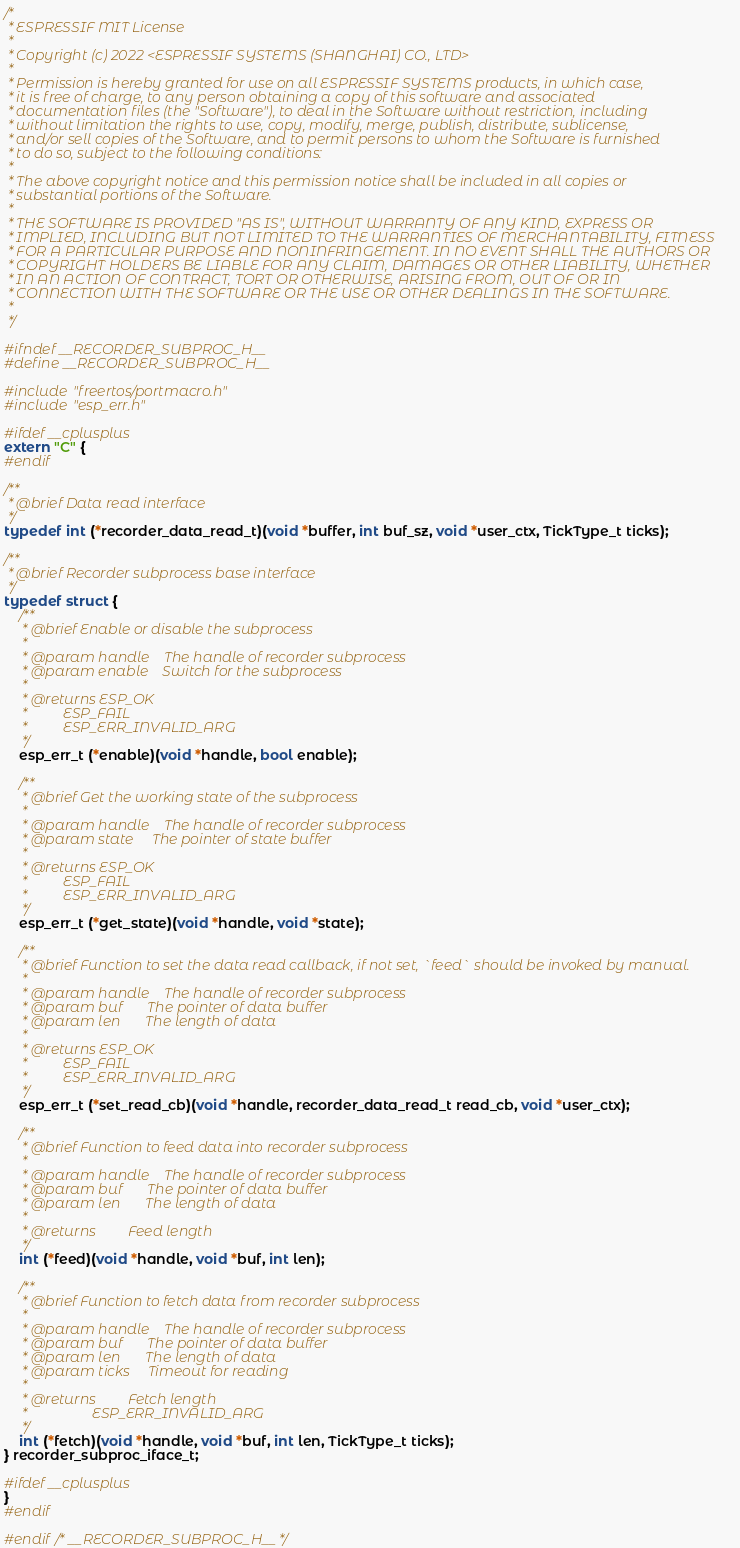Convert code to text. <code><loc_0><loc_0><loc_500><loc_500><_C_>/*
 * ESPRESSIF MIT License
 *
 * Copyright (c) 2022 <ESPRESSIF SYSTEMS (SHANGHAI) CO., LTD>
 *
 * Permission is hereby granted for use on all ESPRESSIF SYSTEMS products, in which case,
 * it is free of charge, to any person obtaining a copy of this software and associated
 * documentation files (the "Software"), to deal in the Software without restriction, including
 * without limitation the rights to use, copy, modify, merge, publish, distribute, sublicense,
 * and/or sell copies of the Software, and to permit persons to whom the Software is furnished
 * to do so, subject to the following conditions:
 *
 * The above copyright notice and this permission notice shall be included in all copies or
 * substantial portions of the Software.
 *
 * THE SOFTWARE IS PROVIDED "AS IS", WITHOUT WARRANTY OF ANY KIND, EXPRESS OR
 * IMPLIED, INCLUDING BUT NOT LIMITED TO THE WARRANTIES OF MERCHANTABILITY, FITNESS
 * FOR A PARTICULAR PURPOSE AND NONINFRINGEMENT. IN NO EVENT SHALL THE AUTHORS OR
 * COPYRIGHT HOLDERS BE LIABLE FOR ANY CLAIM, DAMAGES OR OTHER LIABILITY, WHETHER
 * IN AN ACTION OF CONTRACT, TORT OR OTHERWISE, ARISING FROM, OUT OF OR IN
 * CONNECTION WITH THE SOFTWARE OR THE USE OR OTHER DEALINGS IN THE SOFTWARE.
 *
 */

#ifndef __RECORDER_SUBPROC_H__
#define __RECORDER_SUBPROC_H__

#include "freertos/portmacro.h"
#include "esp_err.h"

#ifdef __cplusplus
extern "C" {
#endif

/**
 * @brief Data read interface
 */
typedef int (*recorder_data_read_t)(void *buffer, int buf_sz, void *user_ctx, TickType_t ticks);

/**
 * @brief Recorder subprocess base interface
 */
typedef struct {
    /**
     * @brief Enable or disable the subprocess
     *
     * @param handle    The handle of recorder subprocess
     * @param enable    Switch for the subprocess
     *
     * @returns ESP_OK
     *          ESP_FAIL
     *          ESP_ERR_INVALID_ARG
     */
    esp_err_t (*enable)(void *handle, bool enable);

    /**
     * @brief Get the working state of the subprocess
     *
     * @param handle    The handle of recorder subprocess
     * @param state     The pointer of state buffer
     *
     * @returns ESP_OK
     *          ESP_FAIL
     *          ESP_ERR_INVALID_ARG
     */
    esp_err_t (*get_state)(void *handle, void *state);

    /**
     * @brief Function to set the data read callback, if not set, `feed` should be invoked by manual.
     *
     * @param handle    The handle of recorder subprocess
     * @param buf       The pointer of data buffer
     * @param len       The length of data
     *
     * @returns ESP_OK
     *          ESP_FAIL
     *          ESP_ERR_INVALID_ARG
     */
    esp_err_t (*set_read_cb)(void *handle, recorder_data_read_t read_cb, void *user_ctx);

    /**
     * @brief Function to feed data into recorder subprocess
     *
     * @param handle    The handle of recorder subprocess
     * @param buf       The pointer of data buffer
     * @param len       The length of data
     *
     * @returns         Feed length
     */
    int (*feed)(void *handle, void *buf, int len);

    /**
     * @brief Function to fetch data from recorder subprocess
     *
     * @param handle    The handle of recorder subprocess
     * @param buf       The pointer of data buffer
     * @param len       The length of data
     * @param ticks     Timeout for reading
     *
     * @returns         Fetch length
     *                  ESP_ERR_INVALID_ARG
     */
    int (*fetch)(void *handle, void *buf, int len, TickType_t ticks);
} recorder_subproc_iface_t;

#ifdef __cplusplus
}
#endif

#endif /* __RECORDER_SUBPROC_H__ */
</code> 